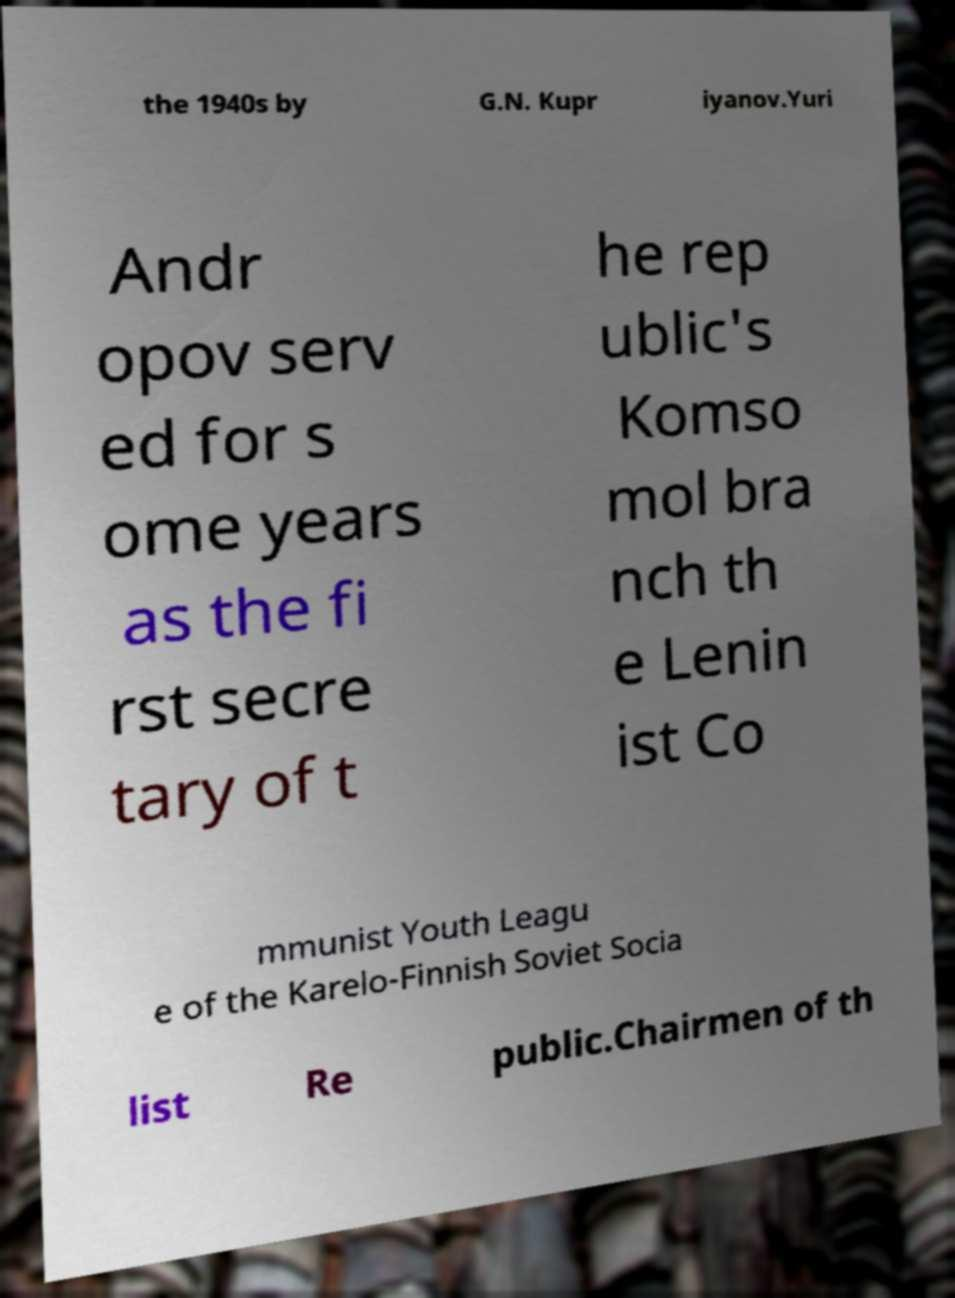Can you read and provide the text displayed in the image?This photo seems to have some interesting text. Can you extract and type it out for me? the 1940s by G.N. Kupr iyanov.Yuri Andr opov serv ed for s ome years as the fi rst secre tary of t he rep ublic's Komso mol bra nch th e Lenin ist Co mmunist Youth Leagu e of the Karelo-Finnish Soviet Socia list Re public.Chairmen of th 